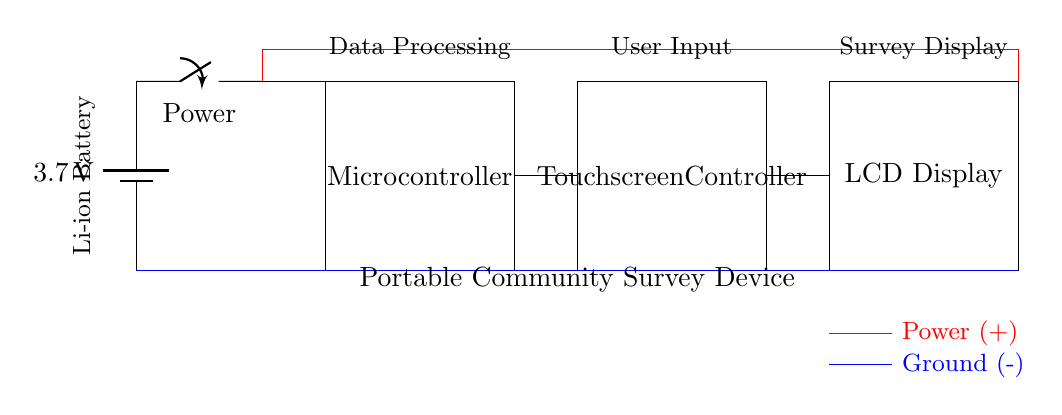What is the voltage of the battery? The voltage is 3.7 volts, as indicated next to the battery symbol in the circuit diagram.
Answer: 3.7 volts What components are used in this circuit? The components include a battery, power switch, microcontroller, touchscreen controller, and an LCD display, which are all labeled in the circuit diagram.
Answer: Battery, switch, microcontroller, touchscreen controller, LCD display Which component is responsible for user input? The touchscreen controller is labeled in the circuit, indicating it processes the input from the user through touch.
Answer: Touchscreen controller How is the power distributed in this circuit? The power flows from the battery through the power switch, then to all other components connected in parallel, ensuring they all receive power simultaneously.
Answer: In parallel What is the purpose of the switch in this circuit? The switch serves to control the flow of power from the battery to the rest of the circuit, allowing the device to be turned on or off.
Answer: Control the power flow What does the microcontroller do in this device? The microcontroller processes data, making it responsible for managing inputs from the touchscreen and controlling what is displayed on the LCD.
Answer: Data processing What type of circuit is represented here? The circuit is a portable electronic device designed for community surveys, featuring input and output interfaces for interaction.
Answer: Portable survey device 